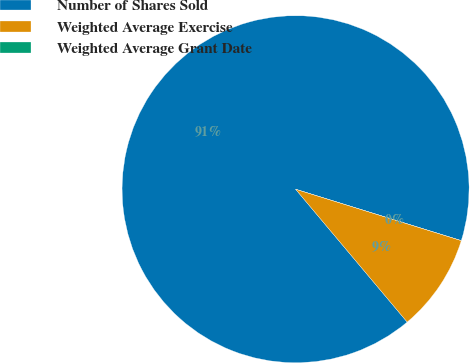Convert chart to OTSL. <chart><loc_0><loc_0><loc_500><loc_500><pie_chart><fcel>Number of Shares Sold<fcel>Weighted Average Exercise<fcel>Weighted Average Grant Date<nl><fcel>90.9%<fcel>9.09%<fcel>0.0%<nl></chart> 